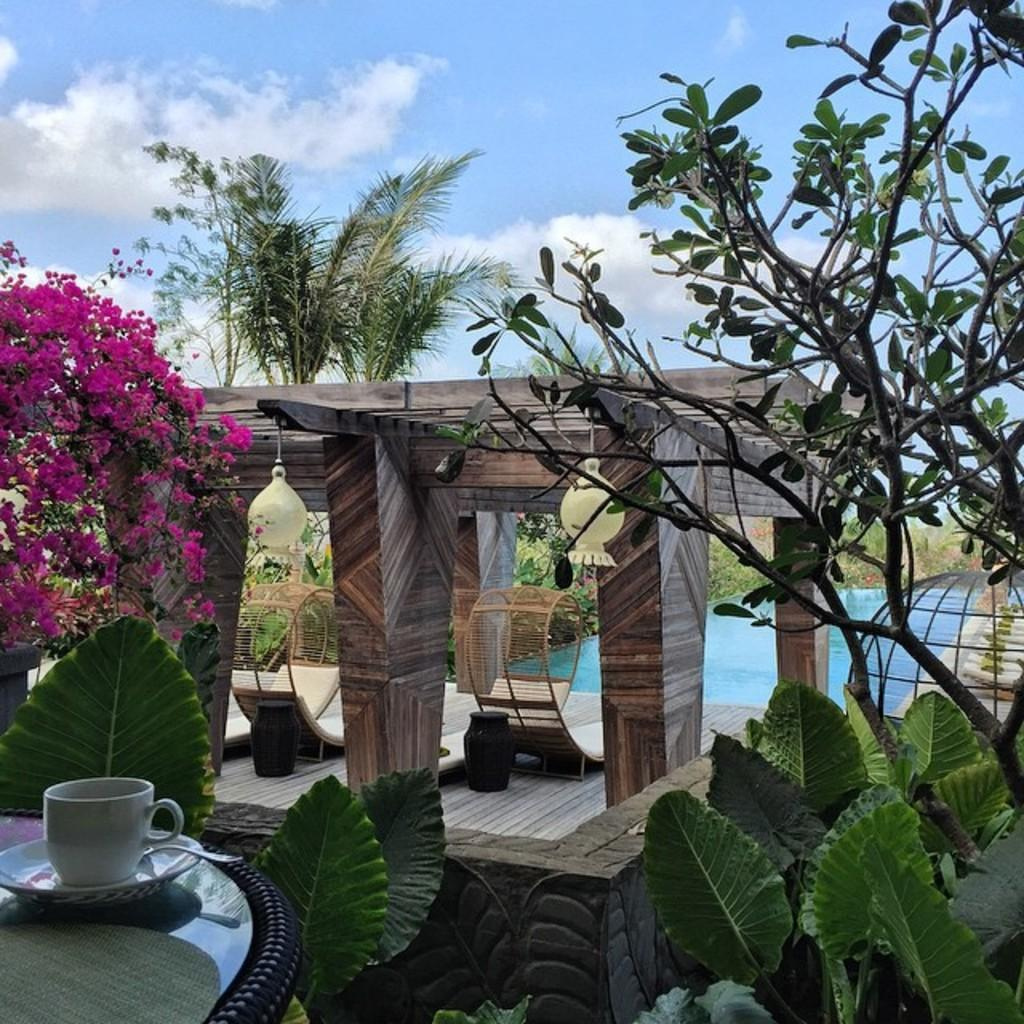What is the main feature in the image? There is a swimming pool in the image. What else can be seen in the image besides the swimming pool? There is a cup of tea, a tree, plants, and a blue sky visible in the image. Can you describe the tree in the image? The tree is a distinct feature in the image, but no specific details about its type or size are provided. What color is the sky in the image? The sky is blue at the top of the image. What type of insurance policy is being discussed in the image? There is no mention of insurance or any discussion in the image; it primarily features a swimming pool and other elements. 